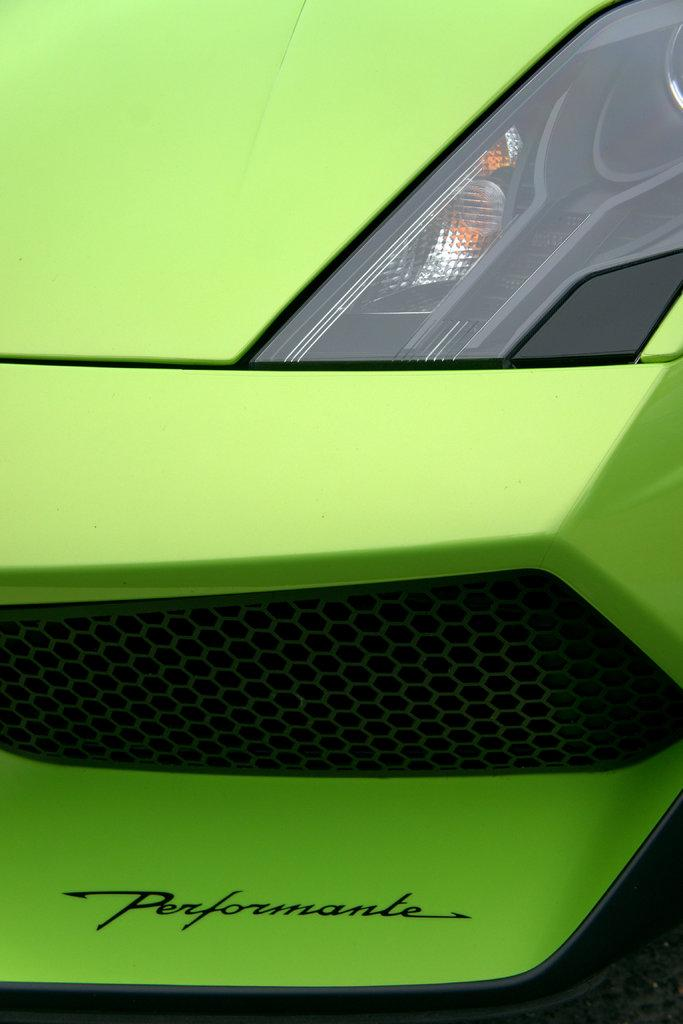What color is the vehicle in the image? The vehicle in the image is green. What type of statement does the police officer make about the vehicle's design in the image? There is no police officer or statement about the vehicle's design in the image. 